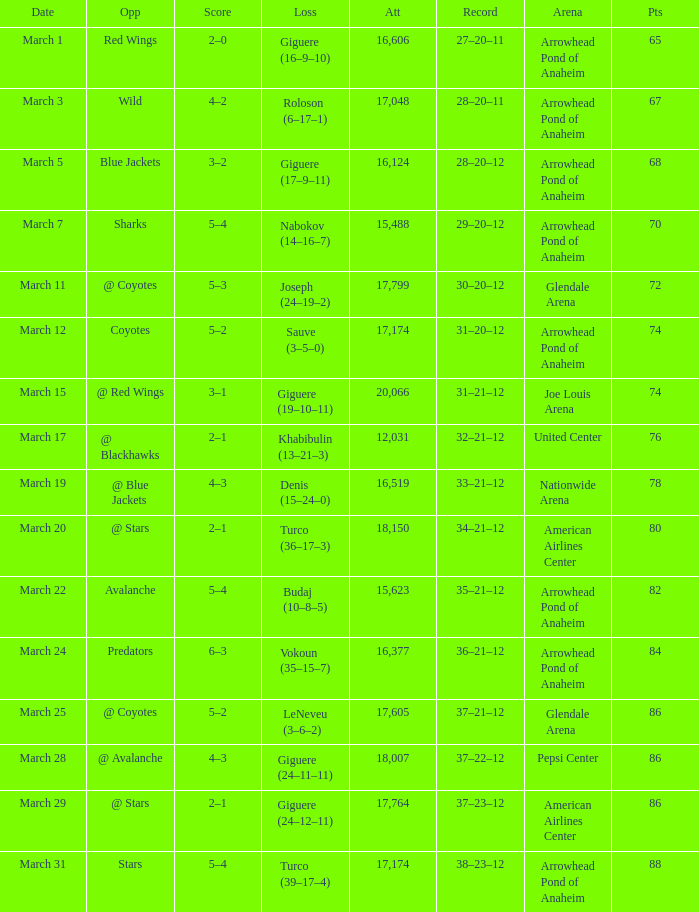Would you mind parsing the complete table? {'header': ['Date', 'Opp', 'Score', 'Loss', 'Att', 'Record', 'Arena', 'Pts'], 'rows': [['March 1', 'Red Wings', '2–0', 'Giguere (16–9–10)', '16,606', '27–20–11', 'Arrowhead Pond of Anaheim', '65'], ['March 3', 'Wild', '4–2', 'Roloson (6–17–1)', '17,048', '28–20–11', 'Arrowhead Pond of Anaheim', '67'], ['March 5', 'Blue Jackets', '3–2', 'Giguere (17–9–11)', '16,124', '28–20–12', 'Arrowhead Pond of Anaheim', '68'], ['March 7', 'Sharks', '5–4', 'Nabokov (14–16–7)', '15,488', '29–20–12', 'Arrowhead Pond of Anaheim', '70'], ['March 11', '@ Coyotes', '5–3', 'Joseph (24–19–2)', '17,799', '30–20–12', 'Glendale Arena', '72'], ['March 12', 'Coyotes', '5–2', 'Sauve (3–5–0)', '17,174', '31–20–12', 'Arrowhead Pond of Anaheim', '74'], ['March 15', '@ Red Wings', '3–1', 'Giguere (19–10–11)', '20,066', '31–21–12', 'Joe Louis Arena', '74'], ['March 17', '@ Blackhawks', '2–1', 'Khabibulin (13–21–3)', '12,031', '32–21–12', 'United Center', '76'], ['March 19', '@ Blue Jackets', '4–3', 'Denis (15–24–0)', '16,519', '33–21–12', 'Nationwide Arena', '78'], ['March 20', '@ Stars', '2–1', 'Turco (36–17–3)', '18,150', '34–21–12', 'American Airlines Center', '80'], ['March 22', 'Avalanche', '5–4', 'Budaj (10–8–5)', '15,623', '35–21–12', 'Arrowhead Pond of Anaheim', '82'], ['March 24', 'Predators', '6–3', 'Vokoun (35–15–7)', '16,377', '36–21–12', 'Arrowhead Pond of Anaheim', '84'], ['March 25', '@ Coyotes', '5–2', 'LeNeveu (3–6–2)', '17,605', '37–21–12', 'Glendale Arena', '86'], ['March 28', '@ Avalanche', '4–3', 'Giguere (24–11–11)', '18,007', '37–22–12', 'Pepsi Center', '86'], ['March 29', '@ Stars', '2–1', 'Giguere (24–12–11)', '17,764', '37–23–12', 'American Airlines Center', '86'], ['March 31', 'Stars', '5–4', 'Turco (39–17–4)', '17,174', '38–23–12', 'Arrowhead Pond of Anaheim', '88']]} What was the crowd size for the game with a final score of 3-2? 1.0. 